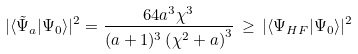<formula> <loc_0><loc_0><loc_500><loc_500>| \langle \tilde { \Psi } _ { a } | \Psi _ { 0 } \rangle | ^ { 2 } = \frac { 6 4 a ^ { 3 } \chi ^ { 3 } } { ( a + 1 ) ^ { 3 } \left ( \chi ^ { 2 } + a \right ) ^ { 3 } } \, \geq \, | \langle { \Psi } _ { H F } | \Psi _ { 0 } \rangle | ^ { 2 }</formula> 